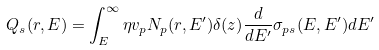Convert formula to latex. <formula><loc_0><loc_0><loc_500><loc_500>Q _ { s } ( r , E ) = \int ^ { \infty } _ { E } \eta v _ { p } N _ { p } ( r , E ^ { \prime } ) \delta ( z ) \frac { d } { d E ^ { \prime } } \sigma _ { p s } ( E , E ^ { \prime } ) d E ^ { \prime }</formula> 